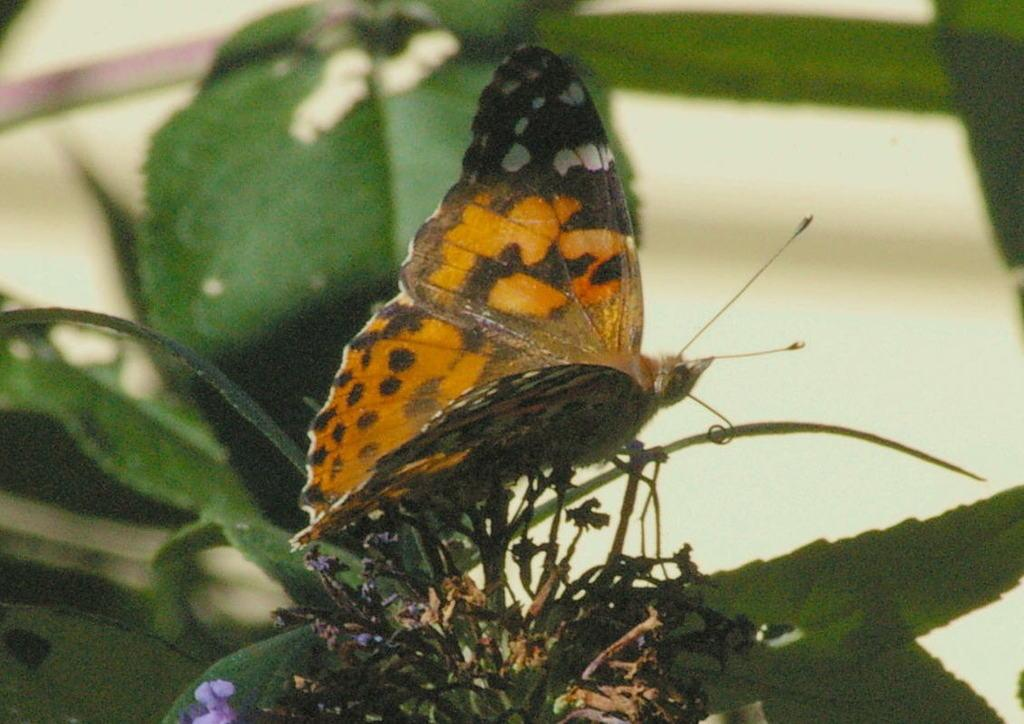What is the main subject of the image? The main subject of the image is a butterfly. Where is the butterfly located in the image? The butterfly is on a plant. Can you tell me how many kittens are playing with a hammer on the plant in the image? There are no kittens or hammers present in the image; it features a butterfly on a plant. 